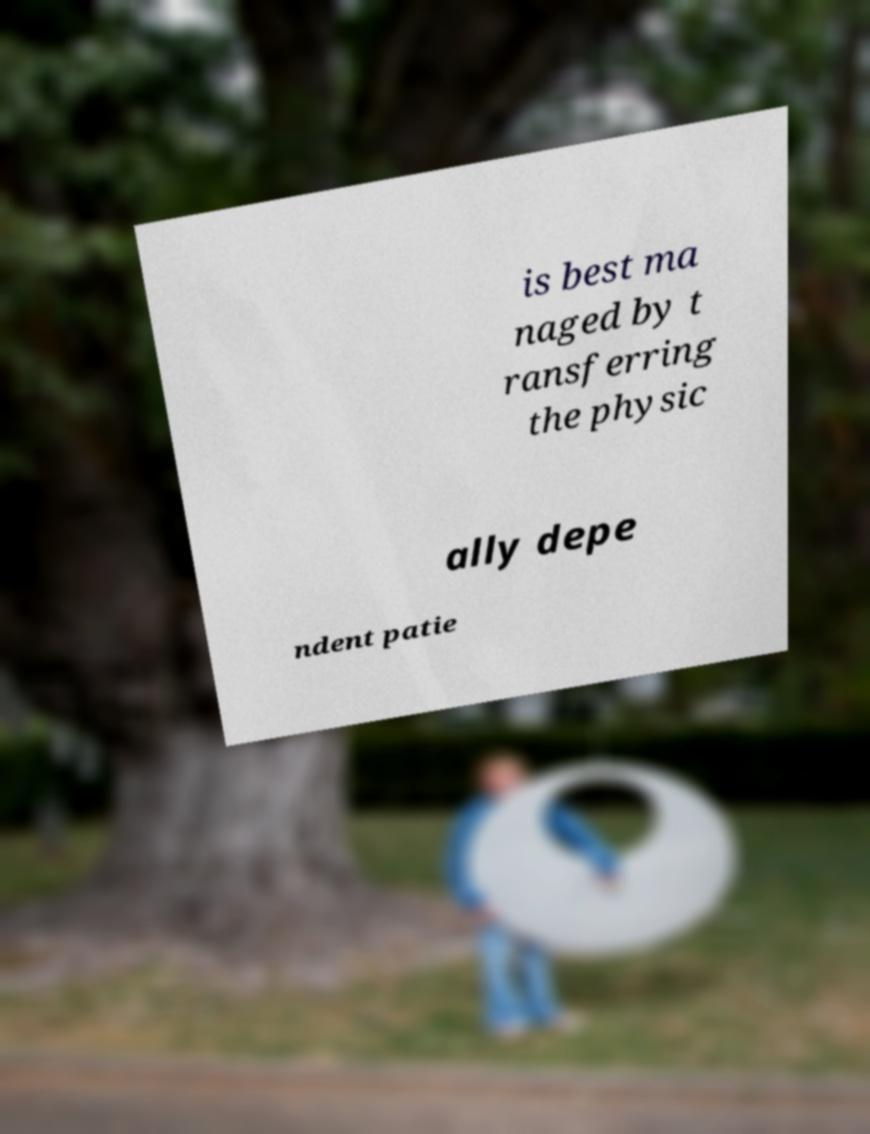Can you accurately transcribe the text from the provided image for me? is best ma naged by t ransferring the physic ally depe ndent patie 